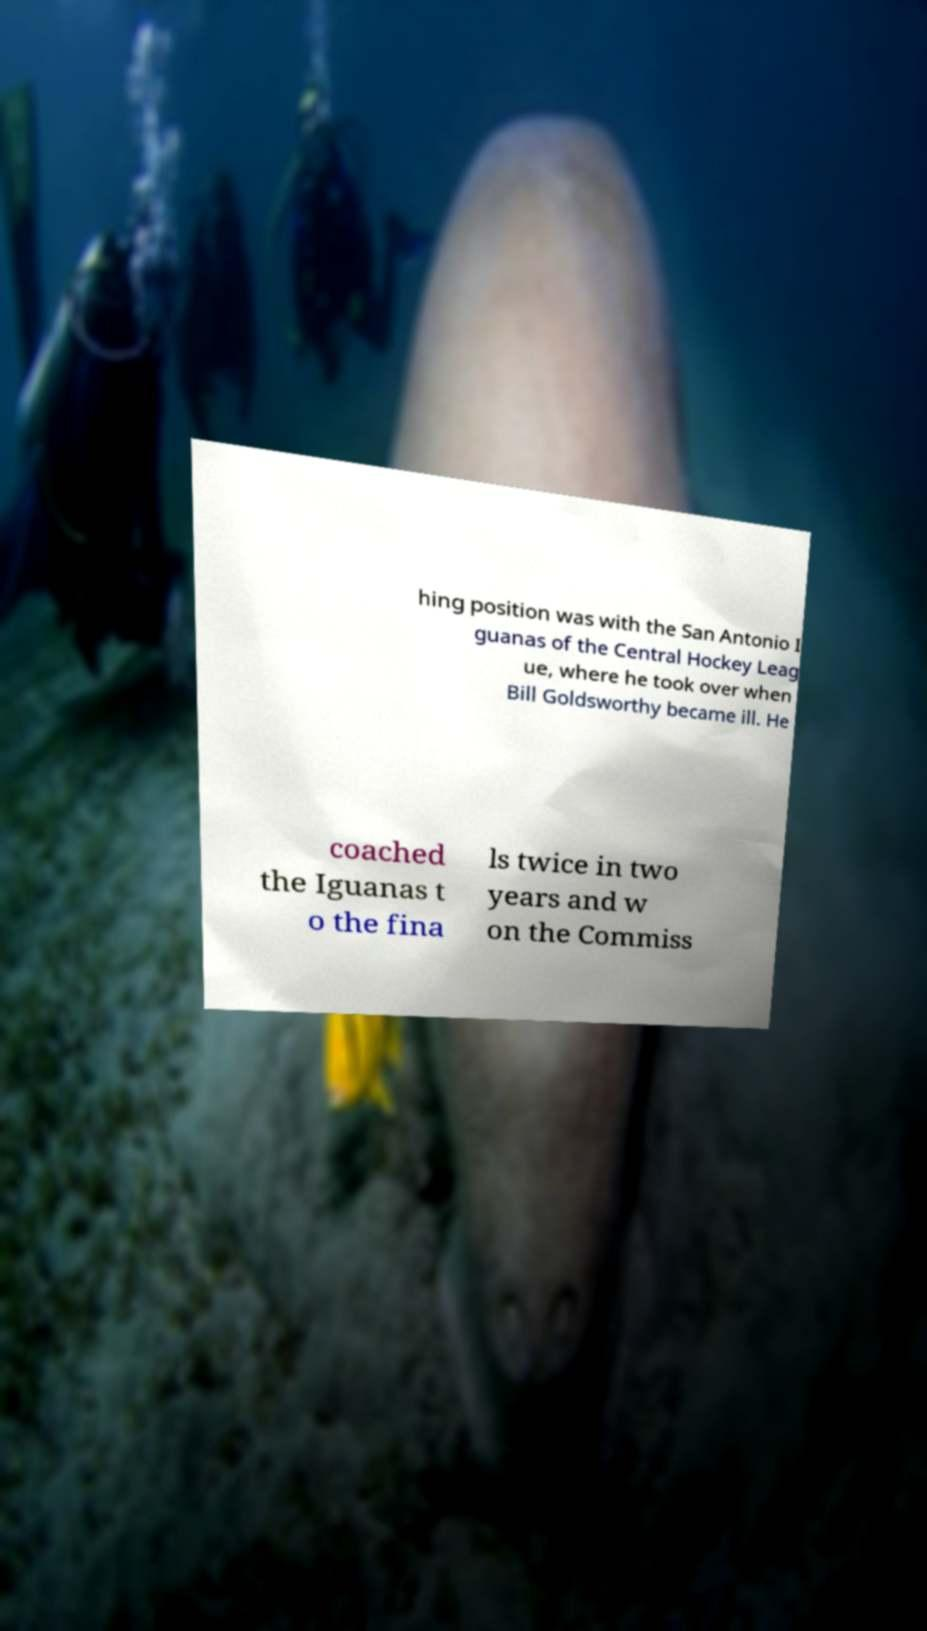Please identify and transcribe the text found in this image. hing position was with the San Antonio I guanas of the Central Hockey Leag ue, where he took over when Bill Goldsworthy became ill. He coached the Iguanas t o the fina ls twice in two years and w on the Commiss 